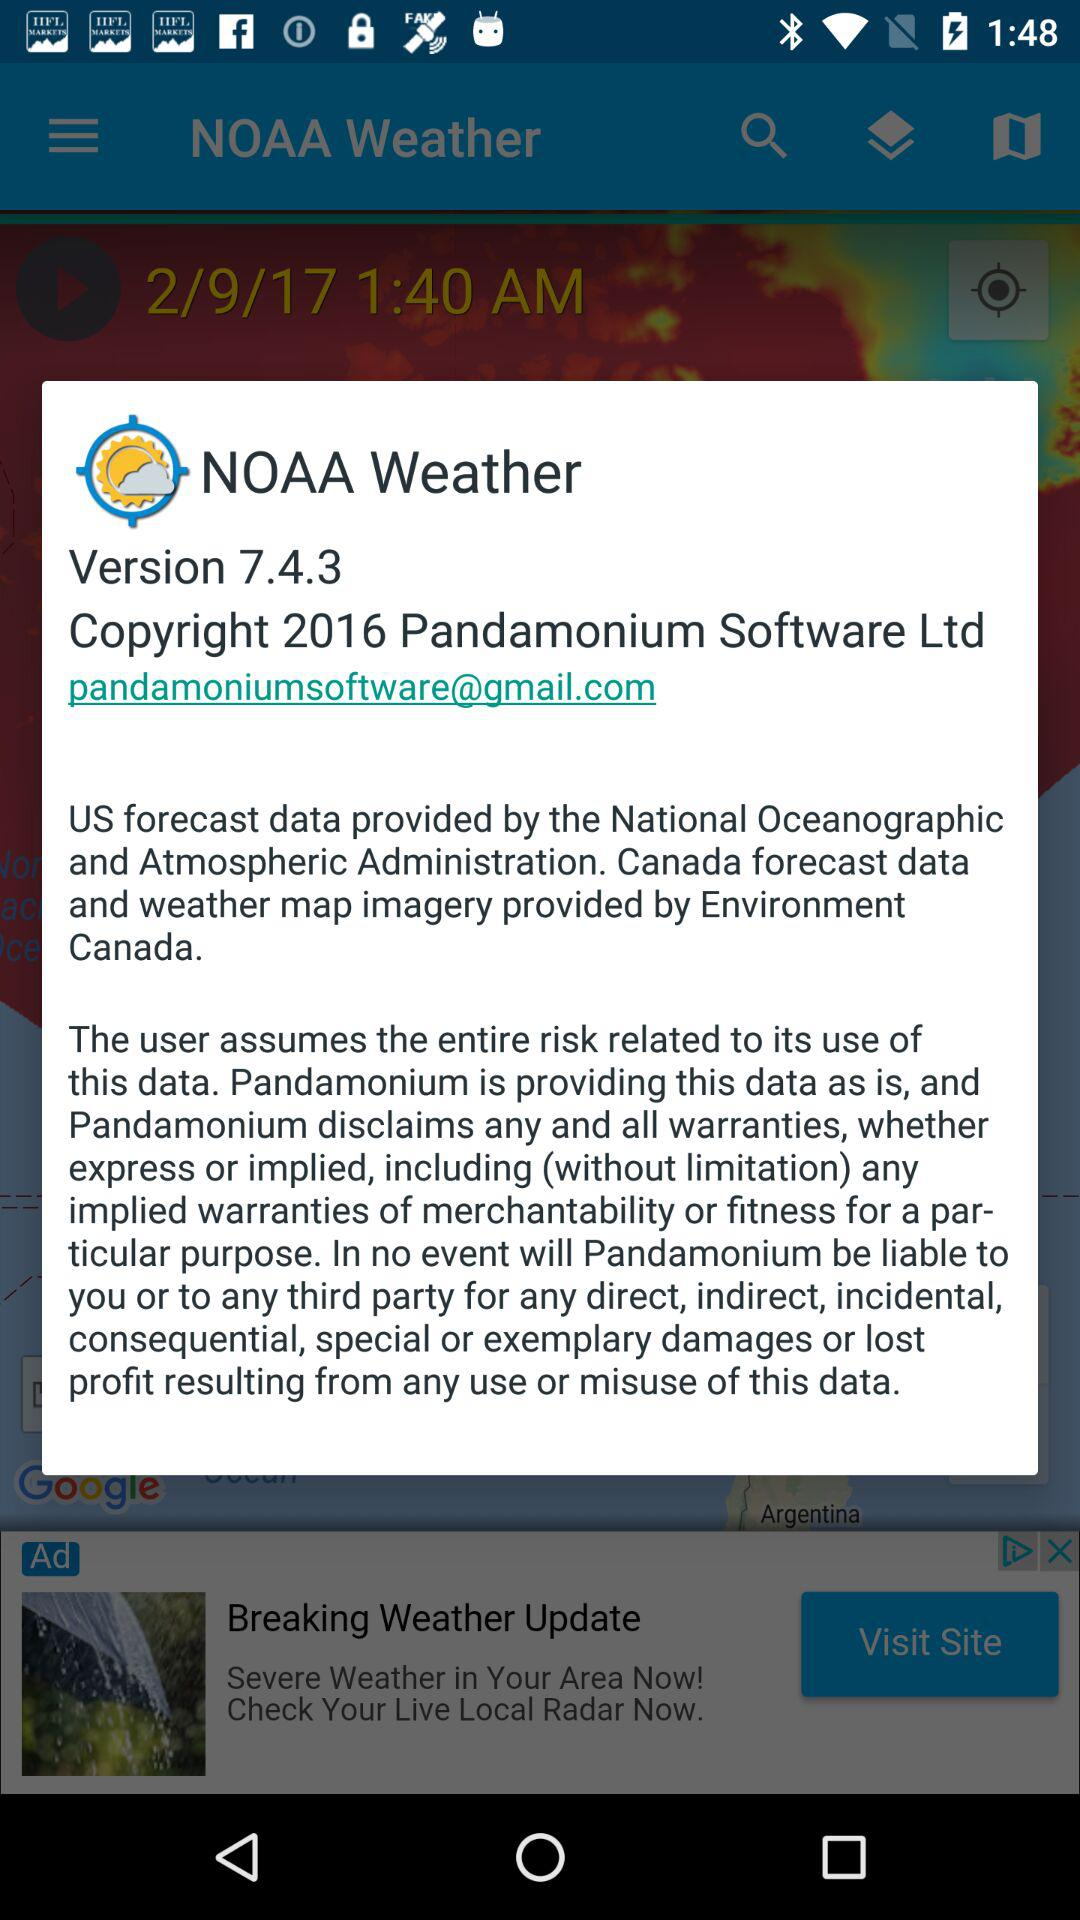What is the email address? The email address is pandamoniumsoftware@gmail.com. 